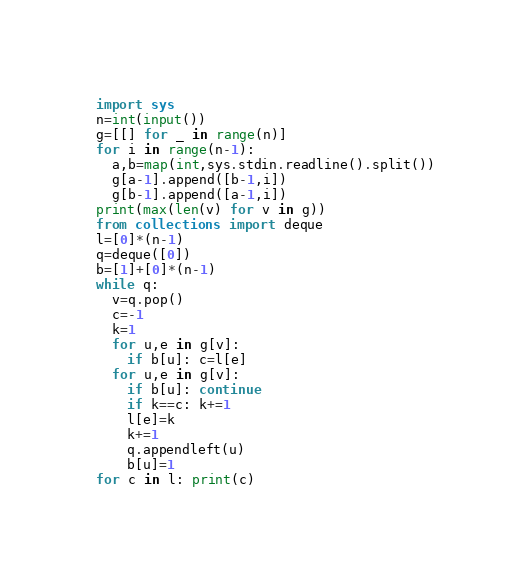Convert code to text. <code><loc_0><loc_0><loc_500><loc_500><_Python_>import sys
n=int(input())
g=[[] for _ in range(n)]
for i in range(n-1):
  a,b=map(int,sys.stdin.readline().split())
  g[a-1].append([b-1,i])
  g[b-1].append([a-1,i])
print(max(len(v) for v in g))
from collections import deque
l=[0]*(n-1)
q=deque([0])
b=[1]+[0]*(n-1)
while q:
  v=q.pop()
  c=-1
  k=1
  for u,e in g[v]:
    if b[u]: c=l[e]
  for u,e in g[v]:
    if b[u]: continue
    if k==c: k+=1
    l[e]=k
    k+=1
    q.appendleft(u)
    b[u]=1
for c in l: print(c)</code> 